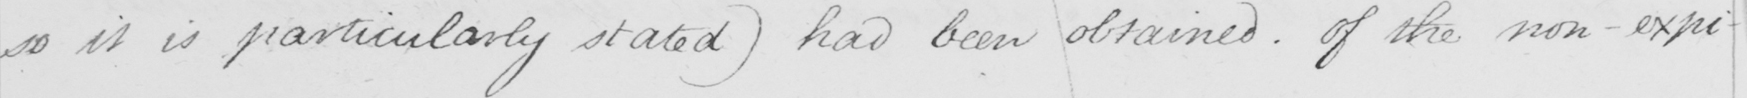What does this handwritten line say? so it is particularly stated )  had been obtained . Of the non-expi- 